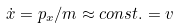Convert formula to latex. <formula><loc_0><loc_0><loc_500><loc_500>\dot { x } = p _ { x } / m \approx c o n s t . = v</formula> 